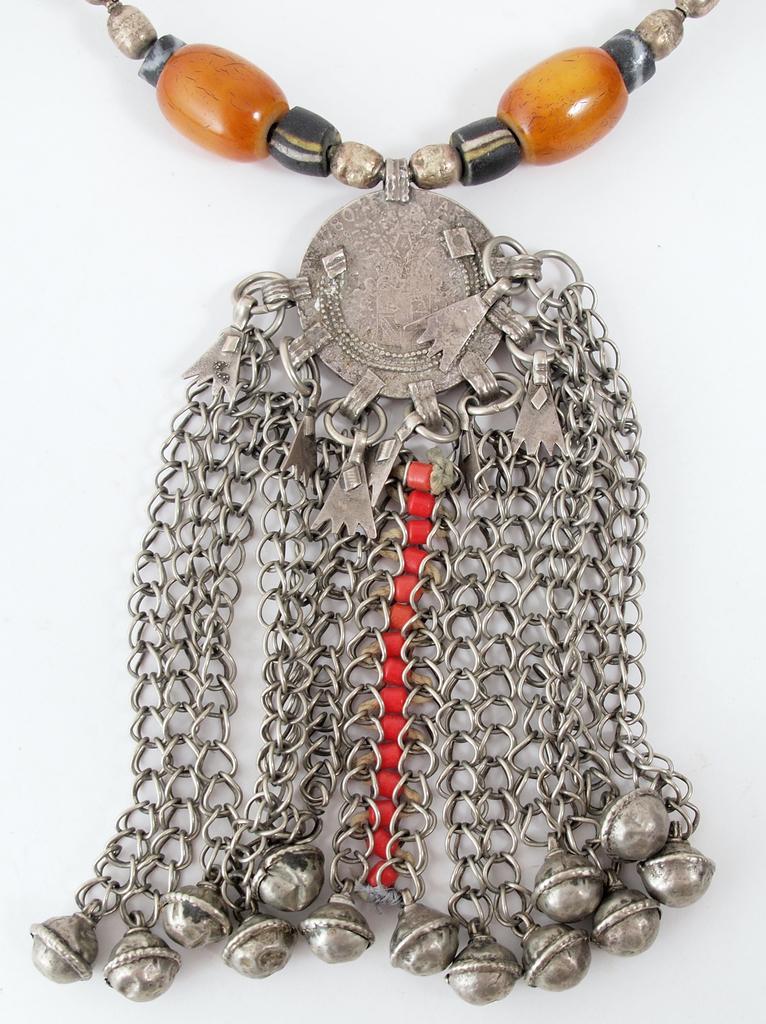Can you describe this image briefly? In this picture we can see jewelry on the white surface. 